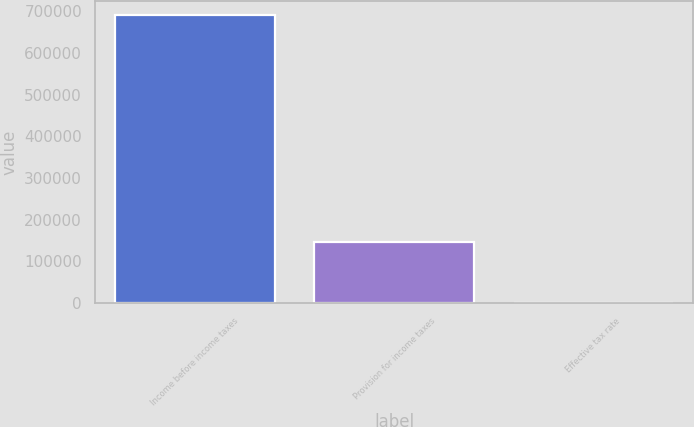<chart> <loc_0><loc_0><loc_500><loc_500><bar_chart><fcel>Income before income taxes<fcel>Provision for income taxes<fcel>Effective tax rate<nl><fcel>690621<fcel>147472<fcel>21.4<nl></chart> 